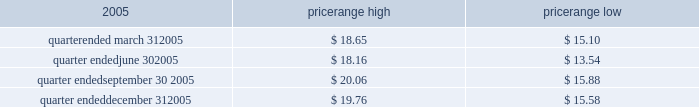Item 4 .
Submission of matters to a vote of security holders no matters were submitted to a vote of security holders during the fourth quarter of 2005 .
Part ii item 5 .
Market for the registrant 2019s common equity , related stockholder matters and issuer purchases of equity securities market information our series a common stock has traded on the new york stock exchange under the symbol 2018 2018ce 2019 2019 since january 21 , 2005 .
The closing sale price of our series a common stock , as reported by the new york stock exchange , on march 6 , 2006 was $ 20.98 .
The table sets forth the high and low intraday sales prices per share of our common stock , as reported by the new york stock exchange , for the periods indicated. .
Holders no shares of celanese 2019s series b common stock are issued and outstanding .
As of march 6 , 2006 , there were 51 holders of record of our series a common stock , and one holder of record of our perpetual preferred stock .
By including persons holding shares in broker accounts under street names , however , we estimate our shareholder base to be approximately 6800 as of march 6 , 2006 .
Dividend policy in july 2005 , our board of directors adopted a policy of declaring , subject to legally available funds , a quarterly cash dividend on each share of our common stock at an annual rate initially equal to approximately 1% ( 1 % ) of the $ 16 price per share in the initial public offering of our series a common stock ( or $ 0.16 per share ) unless our board of directors , in its sole discretion , determines otherwise , commencing the second quarter of 2005 .
Pursuant to this policy , the company paid the quarterly dividends of $ 0.04 per share on august 11 , 2005 , november 1 , 2005 and february 1 , 2006 .
Based on the number of outstanding shares of our series a common stock , the anticipated annual cash dividend is approximately $ 25 million .
However , there is no assurance that sufficient cash will be available in the future to pay such dividend .
Further , such dividends payable to holders of our series a common stock cannot be declared or paid nor can any funds be set aside for the payment thereof , unless we have paid or set aside funds for the payment of all accumulated and unpaid dividends with respect to the shares of our preferred stock , as described below .
Our board of directors may , at any time , modify or revoke our dividend policy on our series a common stock .
We are required under the terms of the preferred stock to pay scheduled quarterly dividends , subject to legally available funds .
For so long as the preferred stock remains outstanding , ( 1 ) we will not declare , pay or set apart funds for the payment of any dividend or other distribution with respect to any junior stock or parity stock and ( 2 ) neither we , nor any of our subsidiaries , will , subject to certain exceptions , redeem , purchase or otherwise acquire for consideration junior stock or parity stock through a sinking fund or otherwise , in each case unless we have paid or set apart funds for the payment of all accumulated and unpaid dividends with respect to the shares of preferred stock and any parity stock for all preceding dividend periods .
Pursuant to this policy , the company paid the quarterly dividends of $ 0.265625 on its 4.25% ( 4.25 % ) convertible perpetual preferred stock on august 1 , 2005 , november 1 , 2005 and february 1 , 2006 .
The anticipated annual cash dividend is approximately $ 10 million. .
What is the maximum variance during the quarter ended in march 31 , 2005? 
Computations: (18.65 - 15.10)
Answer: 3.55. 